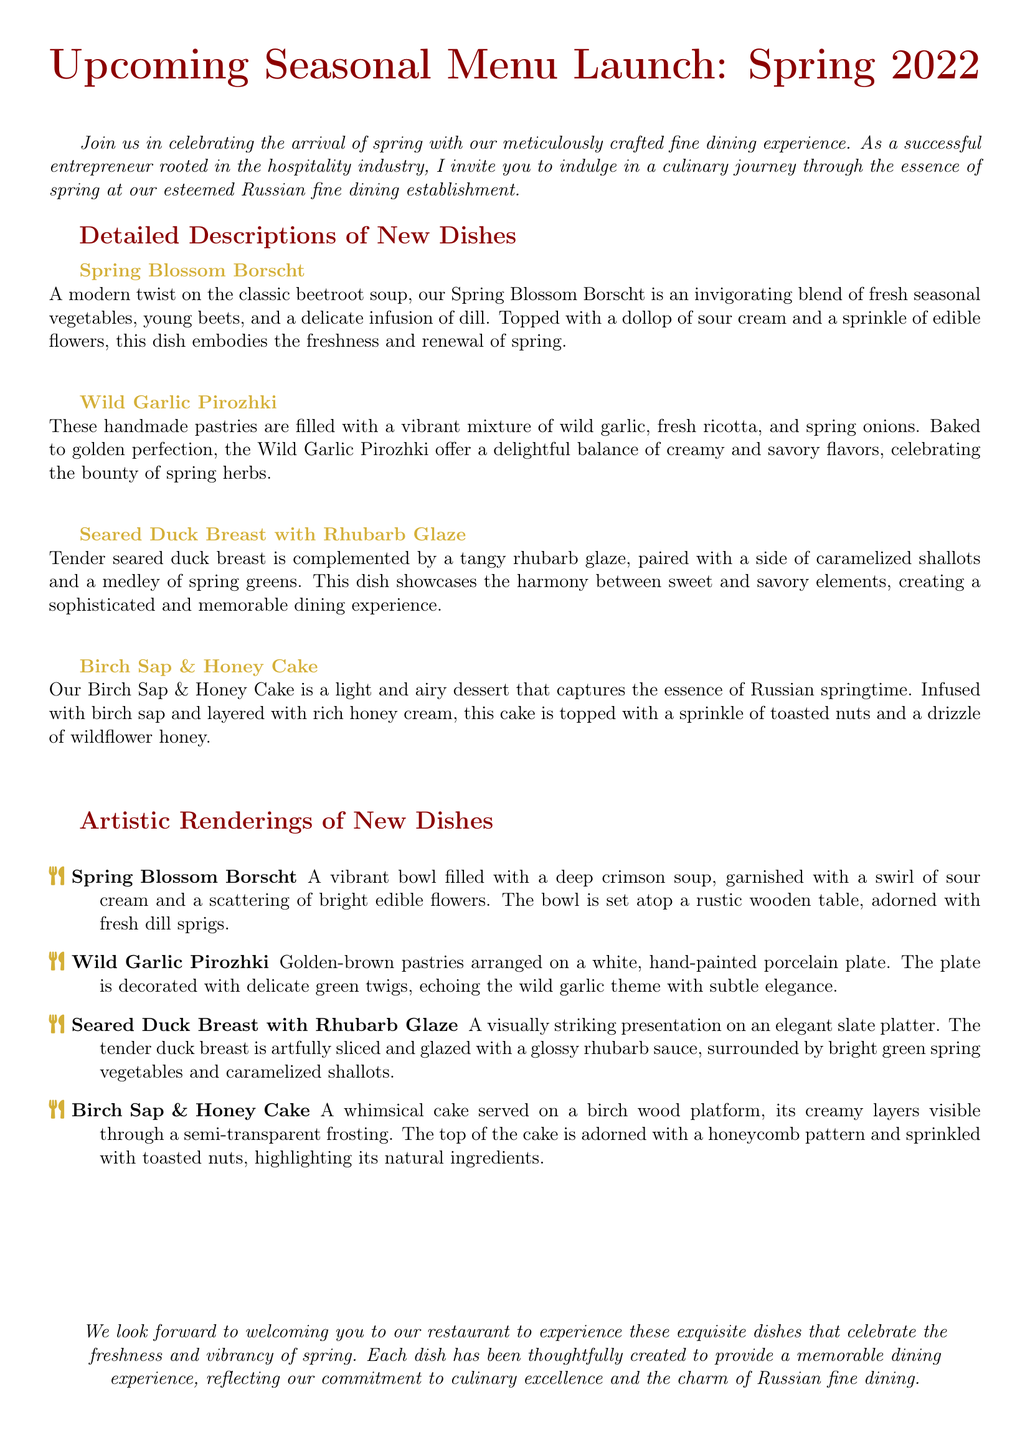What is the title of the event? The title of the event is the first line in the document, which highlights the upcoming seasonal menu launch for the establishment.
Answer: Upcoming Seasonal Menu Launch: Spring 2022 How many new dishes are introduced? The document outlines four new dishes introduced in the spring menu, listed under detailed descriptions.
Answer: Four What is the main ingredient in the Spring Blossom Borscht? The description of the Spring Blossom Borscht states that it is centered around fresh seasonal vegetables and young beets.
Answer: Young beets What type of dessert is featured in the new menu? The document mentions a dessert under detailed descriptions, indicating it is a cake infused with birch sap and honey.
Answer: Birch Sap & Honey Cake What color are the Wild Garlic Pirozhki pastries? The artistic rendering describes the Wild Garlic Pirozhki as golden-brown in color.
Answer: Golden-brown What herb is prominently mentioned in the Spring Blossom Borscht? The description highlights the use of dill as a significant herb in the Spring Blossom Borscht recipe.
Answer: Dill Which dish features rhubarb? The detailed description explicitly states that the Seared Duck Breast is complemented by a tangy rhubarb glaze.
Answer: Seared Duck Breast with Rhubarb Glaze What type of plate is used for the Wild Garlic Pirozhki? The artistic rendering indicates that the Wild Garlic Pirozhki are arranged on a hand-painted porcelain plate.
Answer: Hand-painted porcelain plate 